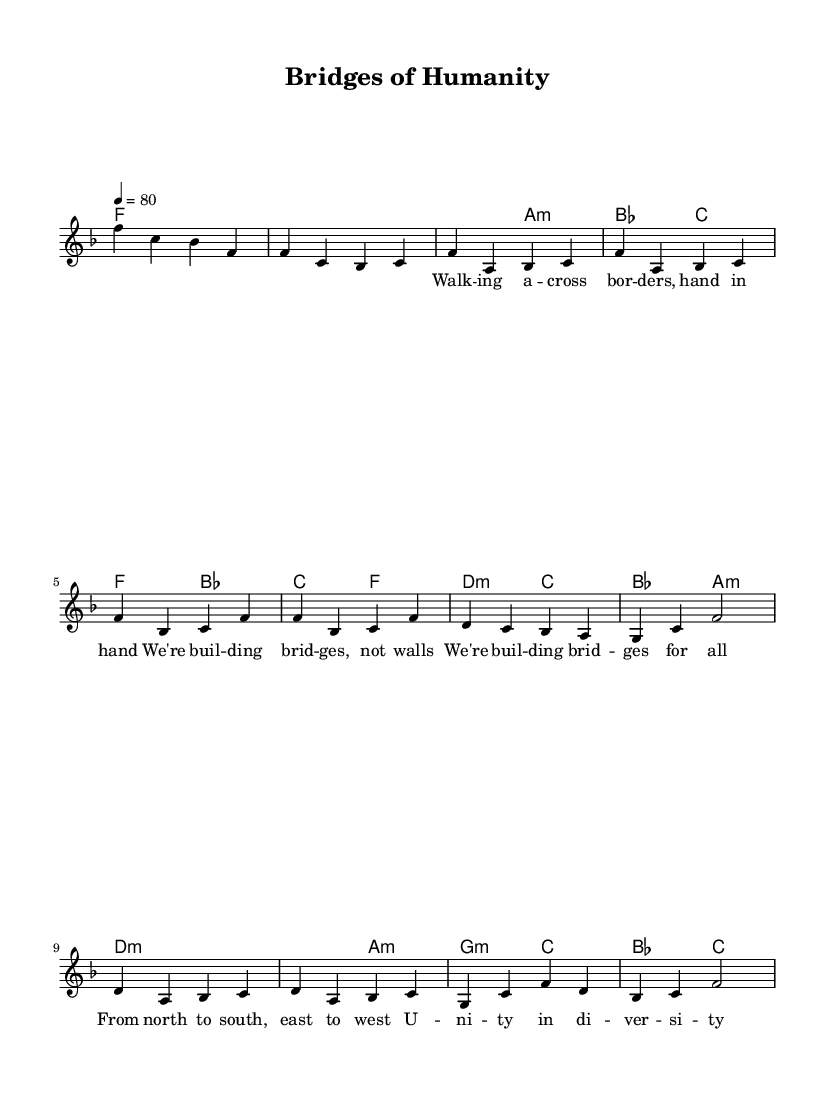What is the key signature of this music? The key signature is F major, which has one flat (B flat). This can be identified from the 'f' indicated in the global section of the music.
Answer: F major What is the time signature of this music? The time signature is 4/4, which is specified in the global section of the music. It indicates that there are four beats in each measure, and the quarter note gets one beat.
Answer: 4/4 What is the tempo of this music? The tempo is indicated as quarter note equals 80, meaning there should be 80 quarter note beats played per minute. This is found in the global section where the tempo is mentioned.
Answer: 80 What chord is played during the chorus? The chords played during the chorus are F major and B flat major, as shown in the harmonies section where the chords are listed in rectangles above the melody line.
Answer: F major and B flat major How many measures are in the bridge section? The bridge section consists of four measures, as indicated by the melody and harmony notations, ranging from the first 'd' chord to the last 'c' chord shown in the bridge part.
Answer: 4 measures What theme does the song reflect in its lyrics? The lyrics reflect a theme of unity and connection, as seen in lines like "We're building bridges, not walls" and "Unity in diversity" that emphasize social justice and human rights. The overall context and phrasing convey messages against division.
Answer: Unity and connection 